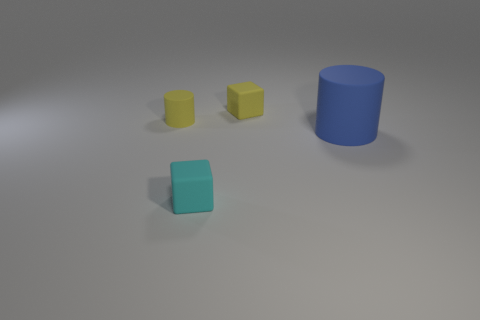Add 2 brown things. How many objects exist? 6 Add 4 small objects. How many small objects are left? 7 Add 2 tiny purple metallic cylinders. How many tiny purple metallic cylinders exist? 2 Subtract 0 cyan spheres. How many objects are left? 4 Subtract all big blue rubber things. Subtract all tiny matte cylinders. How many objects are left? 2 